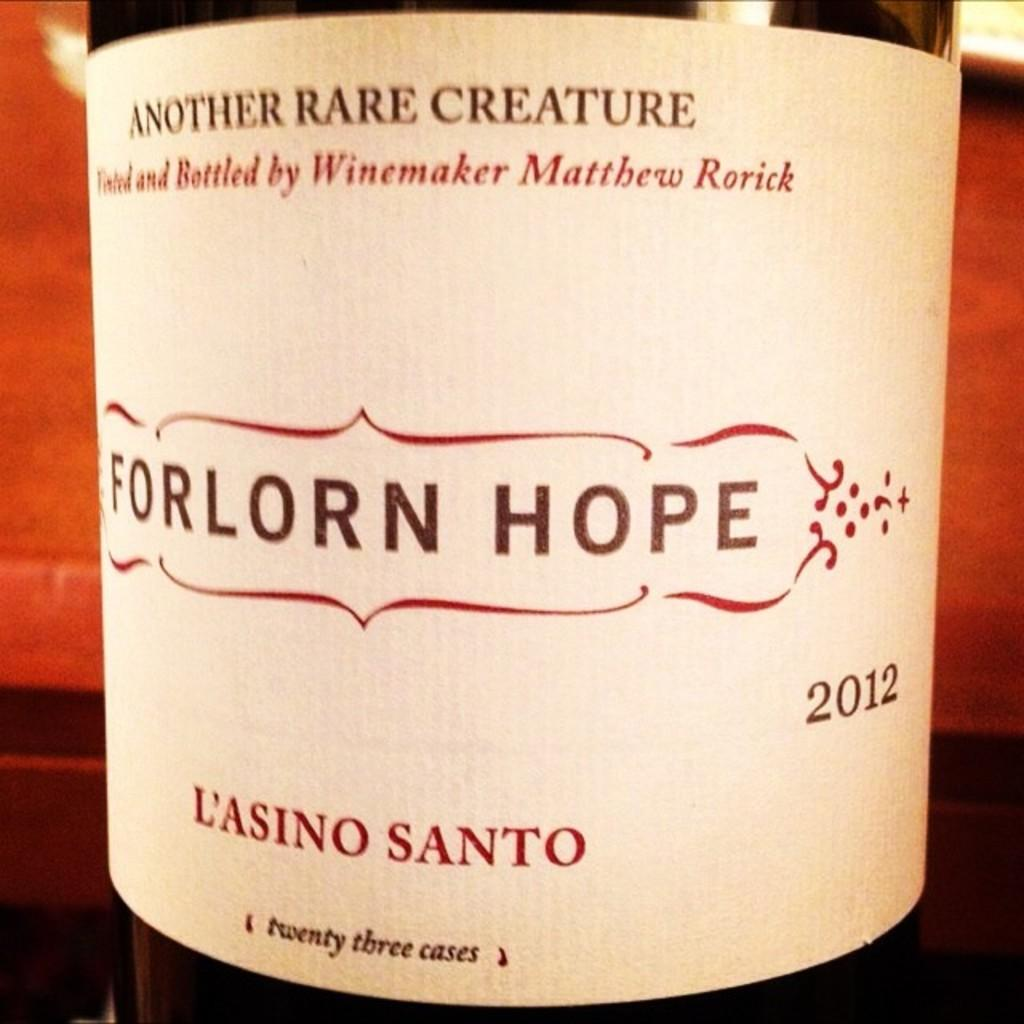<image>
Render a clear and concise summary of the photo. A bottle has the year 2012 printed on the label. 